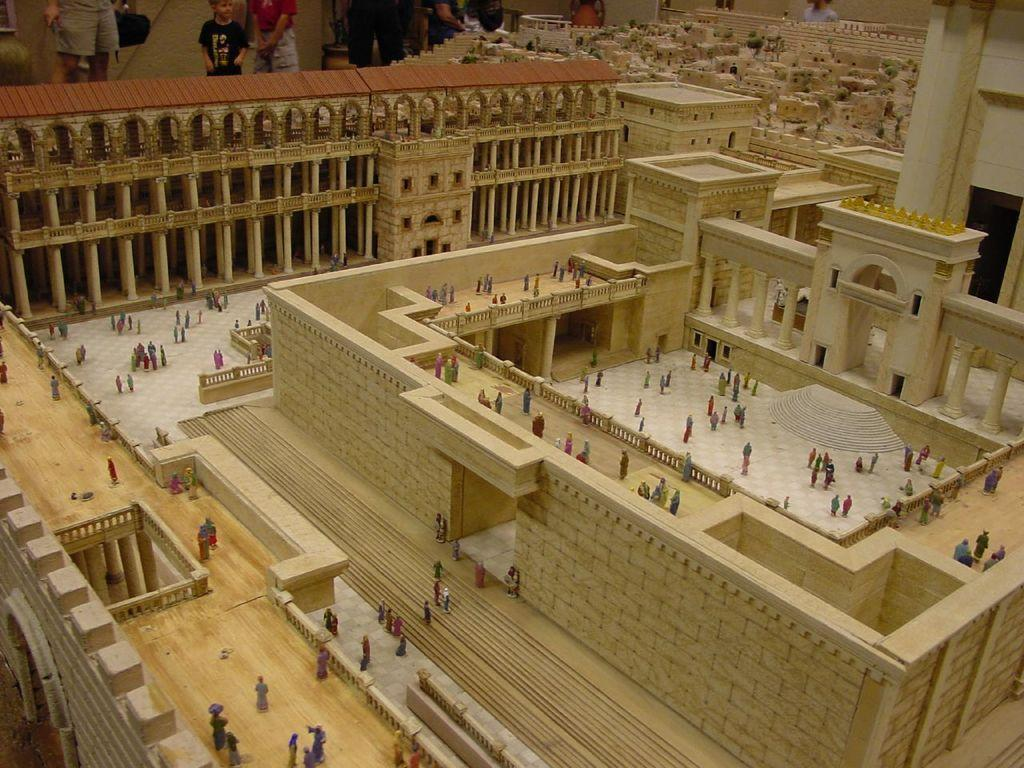What is happening with the group of people in the image? Some people are standing, while others are walking. What can be seen in the background of the image? There are other people standing in the background of the image. What type of buildings are visible in the image? There are cream-colored buildings in the image. How many trucks are parked near the cream-colored buildings in the image? There is no mention of trucks in the image; it only features a group of people and cream-colored buildings. Are there any dogs visible in the image? There is no mention of dogs in the image; it only features a group of people and cream-colored buildings. 